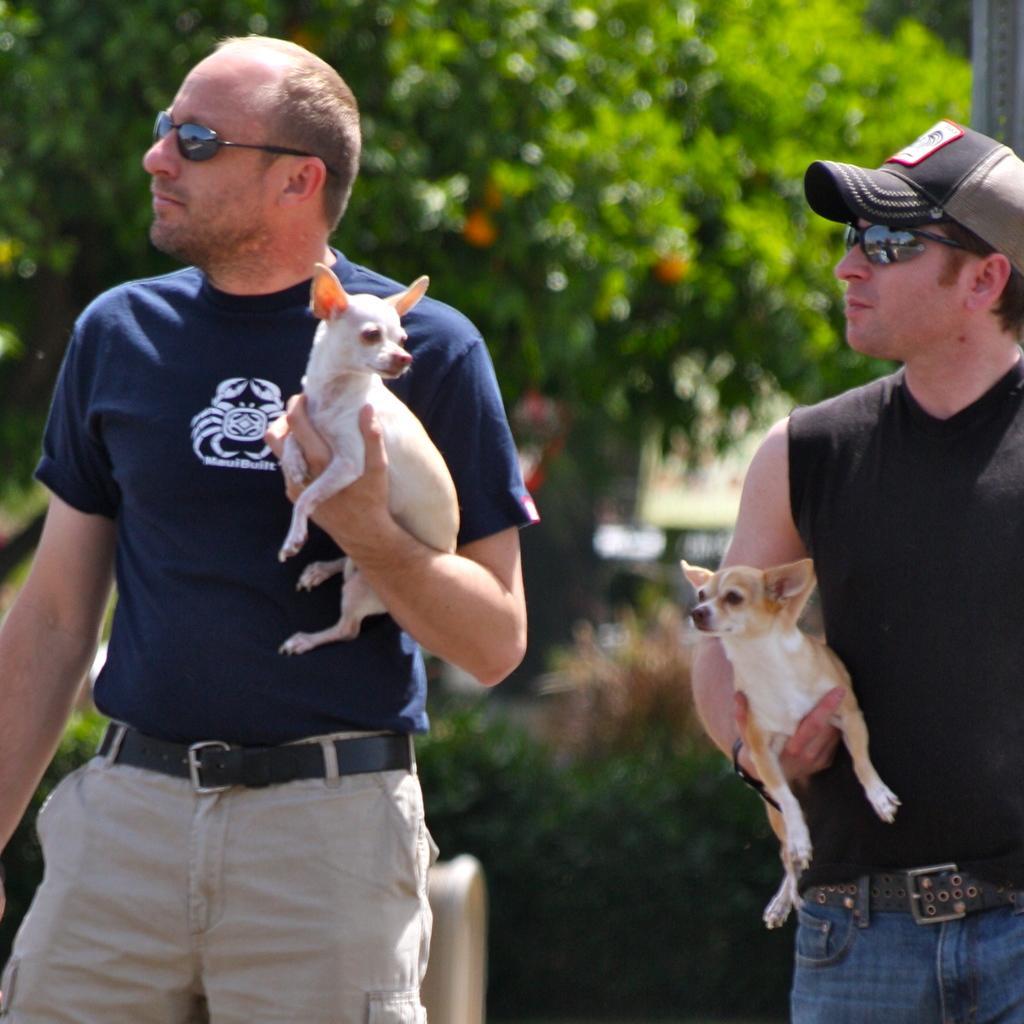Can you describe this image briefly? In this image there are two men, both are holding dogs in their hands. The man to the right is wearing a black sleeveless shirt, and a pant with belt. He is also wearing a cap. And the man to the left is wearing a blue t-shirt with a gray pant and belt. In the background there are trees and plants. 